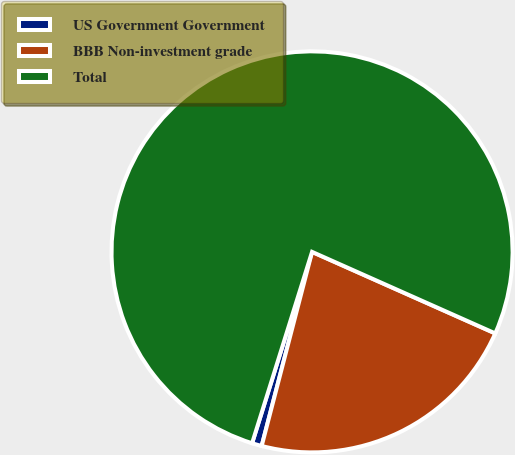<chart> <loc_0><loc_0><loc_500><loc_500><pie_chart><fcel>US Government Government<fcel>BBB Non-investment grade<fcel>Total<nl><fcel>0.79%<fcel>22.38%<fcel>76.83%<nl></chart> 